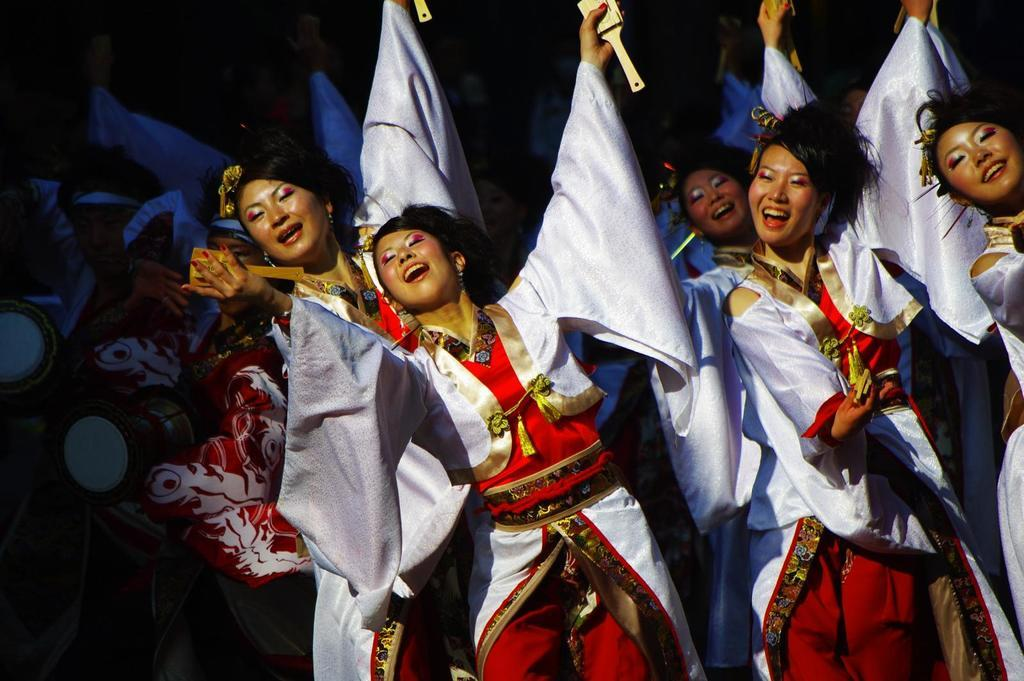Who is present in the image? There are women in the image. What are the women wearing? The women are wearing costumes. What are the women doing in the image? The women are performing. What color is the fish that the women are pulling in the image? There is no fish present in the image, and the women are not pulling anything. 